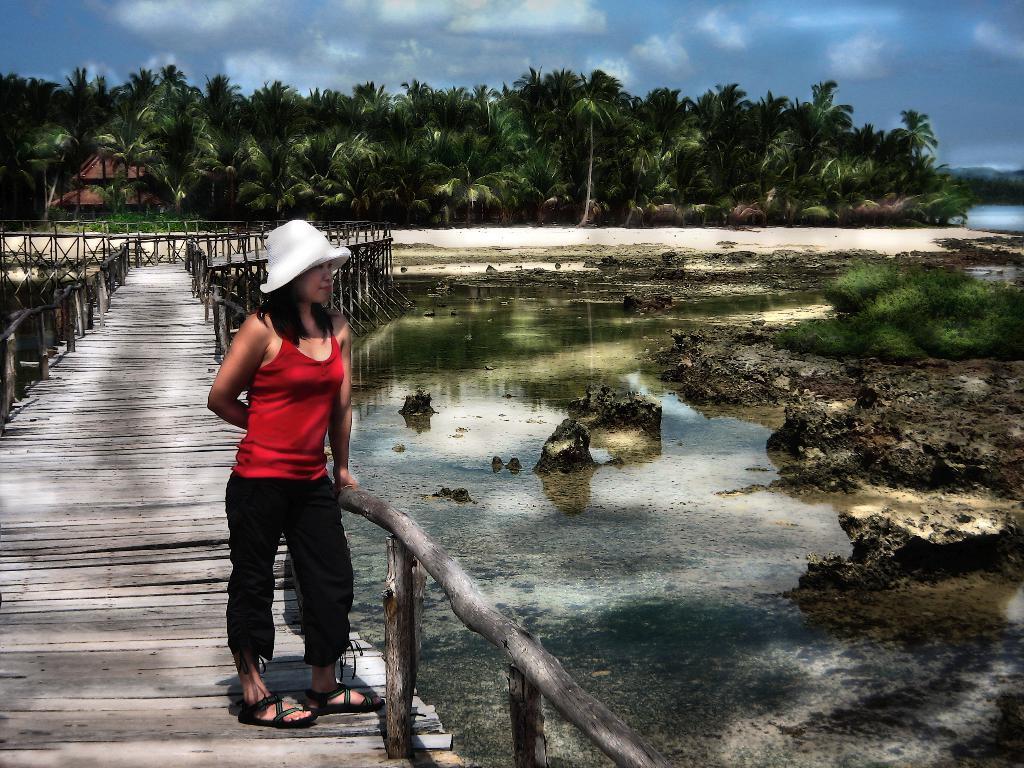Could you give a brief overview of what you see in this image? This is the woman standing. She wore a white hat, red top, trouser and footwear. This looks like a wooden bridge. Here is the water. These are the small plants. These are the coconut trees. I can see the clouds in the sky. 